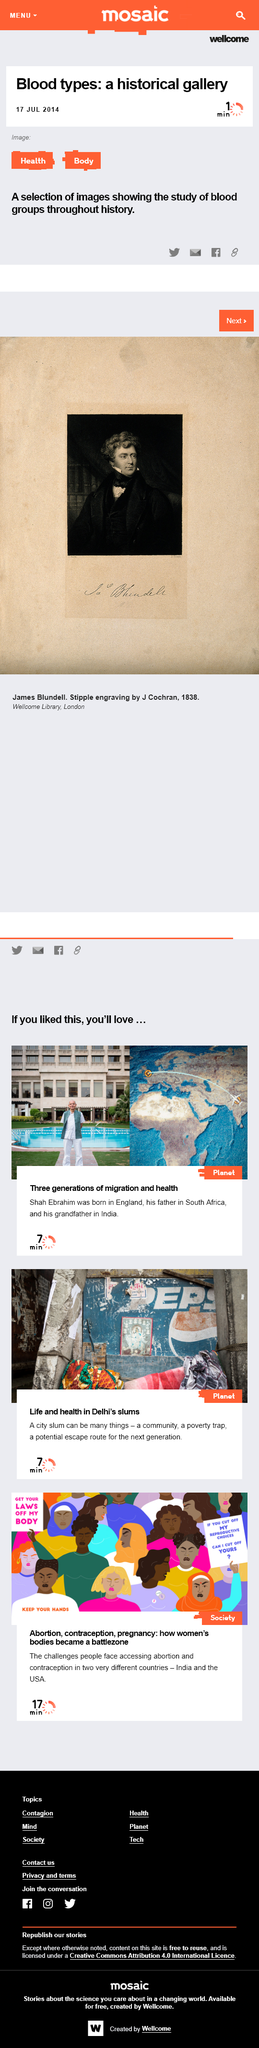Draw attention to some important aspects in this diagram. Shab Ebrahim was born in England. Shab Ebrahim is pictured in the image at the top of the page. Shab Ebrahim's father was born in South Africa. 